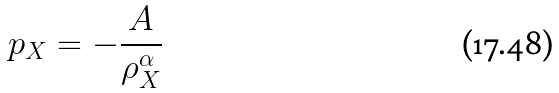Convert formula to latex. <formula><loc_0><loc_0><loc_500><loc_500>p _ { X } = - \frac { A } { \rho _ { X } ^ { \alpha } }</formula> 